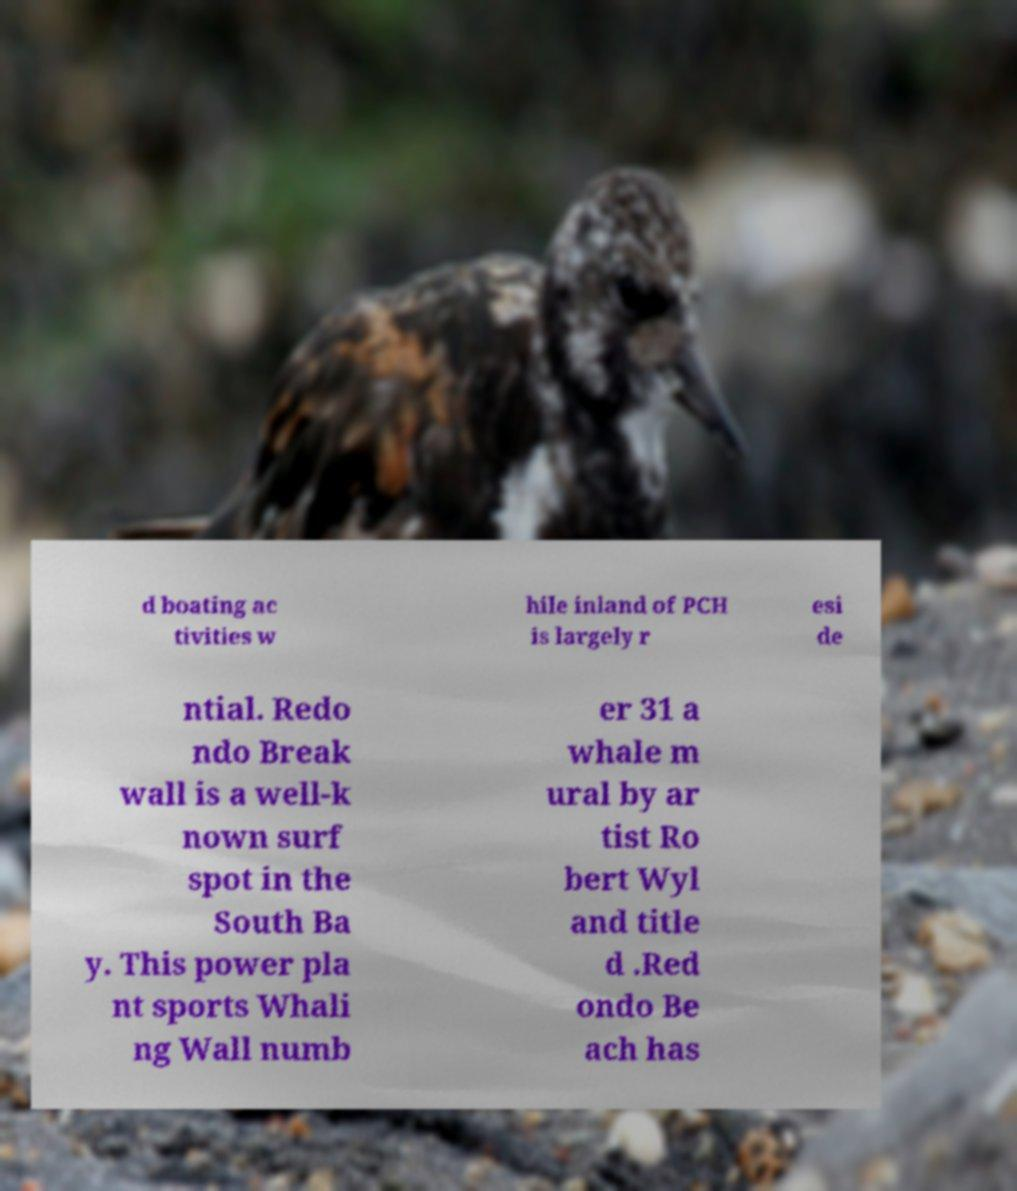What messages or text are displayed in this image? I need them in a readable, typed format. d boating ac tivities w hile inland of PCH is largely r esi de ntial. Redo ndo Break wall is a well-k nown surf spot in the South Ba y. This power pla nt sports Whali ng Wall numb er 31 a whale m ural by ar tist Ro bert Wyl and title d .Red ondo Be ach has 